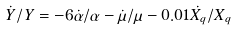<formula> <loc_0><loc_0><loc_500><loc_500>\dot { Y } / Y = - 6 \dot { \alpha } / \alpha - \dot { \mu } / \mu - 0 . 0 1 \dot { X _ { q } } / X _ { q }</formula> 